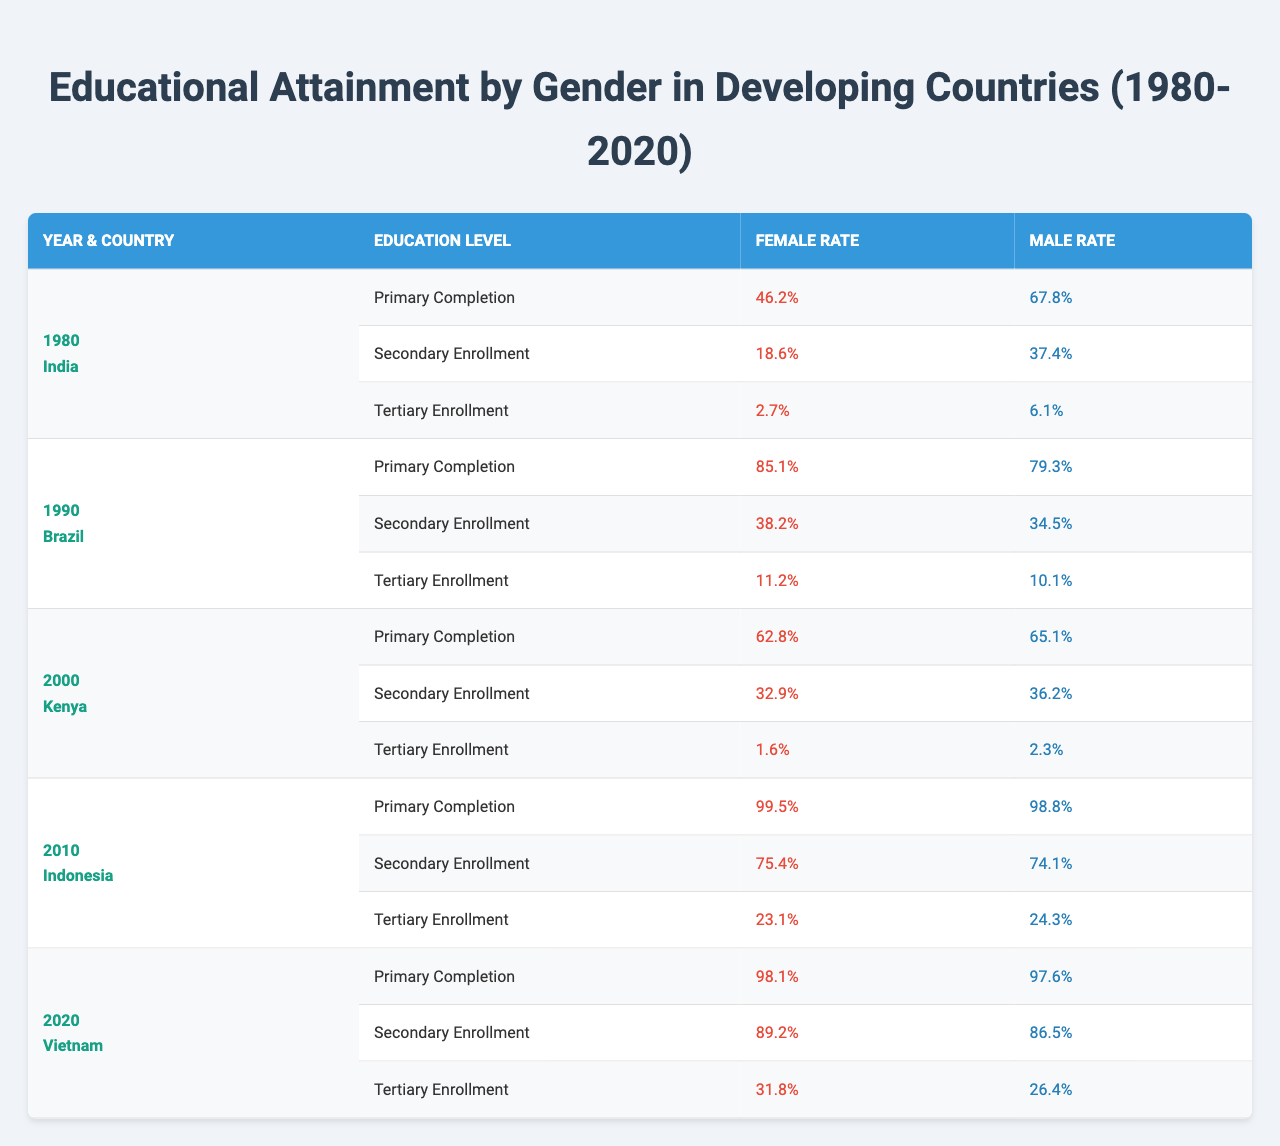What was the female primary completion rate in India in 1980? The table shows that in 1980, the female primary completion rate for India was 46.2%.
Answer: 46.2% Which country had the highest female secondary enrollment in 2010? In 2010, Indonesia had the highest female secondary enrollment at 75.4%.
Answer: Indonesia What is the difference in male primary completion rates between Kenya in 2000 and Vietnam in 2020? In 2000, Kenya's male primary completion rate was 65.1%, while in 2020 Vietnam's rate was 97.6%. The difference is 97.6 - 65.1 = 32.5%.
Answer: 32.5% Did Brazil have a higher female tertiary enrollment than male tertiary enrollment in 1990? In 1990, Brazil's female tertiary enrollment was 11.2% while the male rate was 10.1%, indicating that female enrollment was higher.
Answer: Yes What was the average female primary completion rate across all countries listed for the years provided? The female primary completion rates are 46.2, 85.1, 62.8, 99.5, and 98.1 for India, Brazil, Kenya, Indonesia, and Vietnam respectively. The sum is 46.2 + 85.1 + 62.8 + 99.5 + 98.1 = 391.7, with 5 data points, the average is 391.7 / 5 = 78.34%.
Answer: 78.34% Which country saw the most significant increase in female tertiary enrollment from 1980 to 2020? From the years presented, Vietnam has seen an increase from 0% in 1980 to 31.8% in 2020, while other countries did not have available earlier data for a complete comparison.
Answer: Vietnam Is there a trend in increasing educational completion and enrollment rates for females from 1980 to 2020? Reviewing the data highlights that female completion and enrollment rates have generally increased over the decades provided, especially notable in Indonesia and Vietnam.
Answer: Yes How do male tertiary enrollment rates in 2010 compare to that in 2020 for Vietnam? In 2010, the male tertiary enrollment rate in Vietnam is not present; however, based on the data provided for 2020, it is 26.4%. Therefore, direct comparison cannot be made.
Answer: Cannot compare 